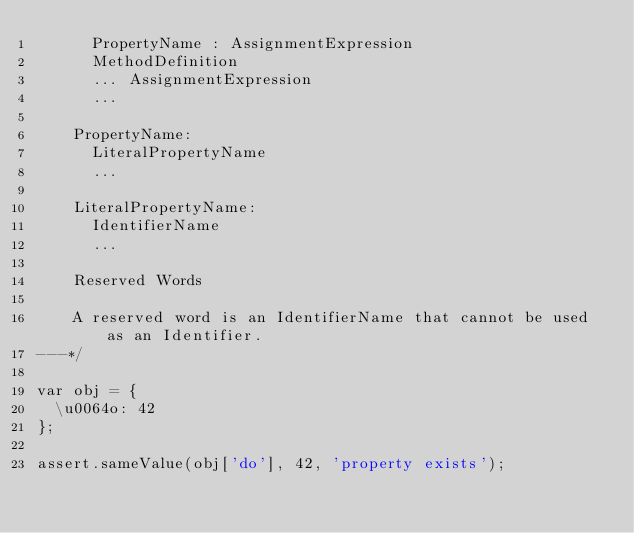<code> <loc_0><loc_0><loc_500><loc_500><_JavaScript_>      PropertyName : AssignmentExpression
      MethodDefinition
      ... AssignmentExpression
      ...

    PropertyName:
      LiteralPropertyName
      ...

    LiteralPropertyName:
      IdentifierName
      ...

    Reserved Words

    A reserved word is an IdentifierName that cannot be used as an Identifier.
---*/

var obj = {
  \u0064o: 42
};

assert.sameValue(obj['do'], 42, 'property exists');
</code> 